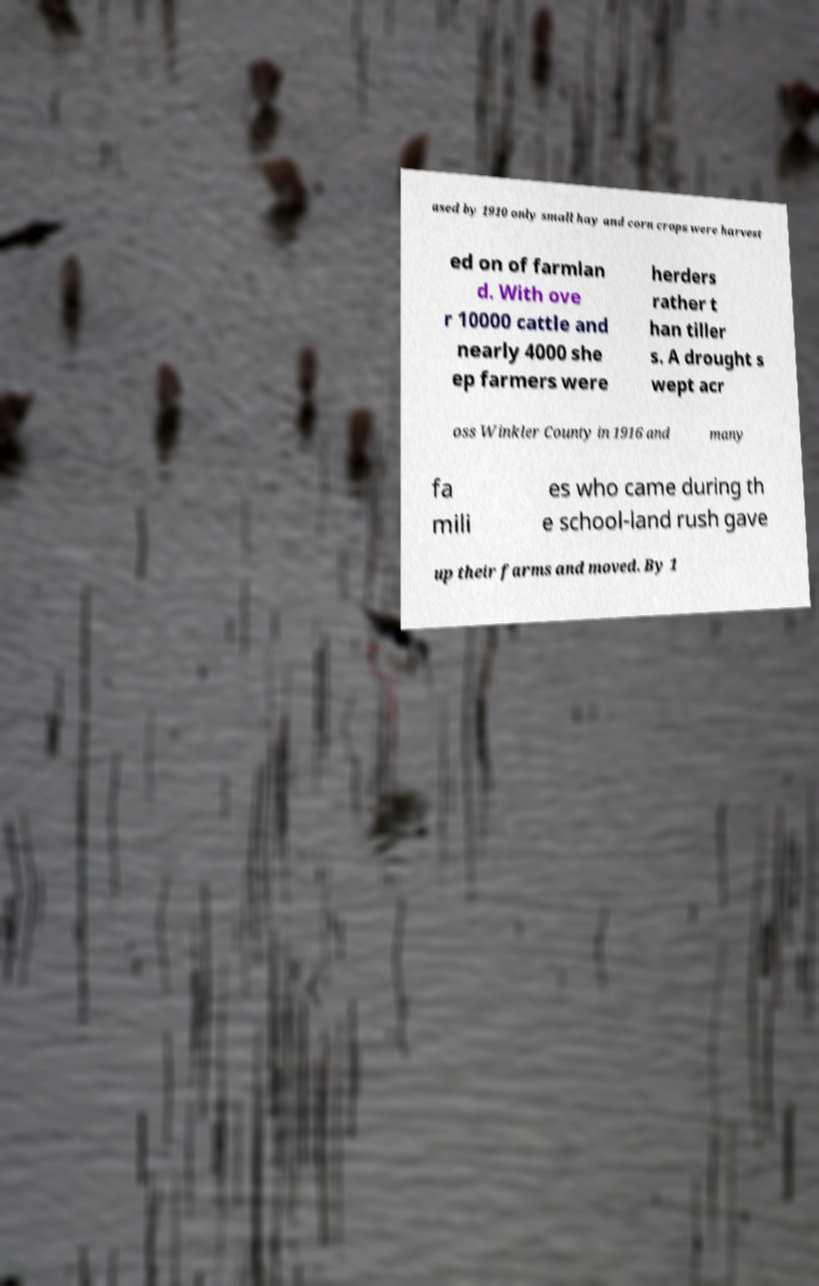Could you assist in decoding the text presented in this image and type it out clearly? ased by 1910 only small hay and corn crops were harvest ed on of farmlan d. With ove r 10000 cattle and nearly 4000 she ep farmers were herders rather t han tiller s. A drought s wept acr oss Winkler County in 1916 and many fa mili es who came during th e school-land rush gave up their farms and moved. By 1 